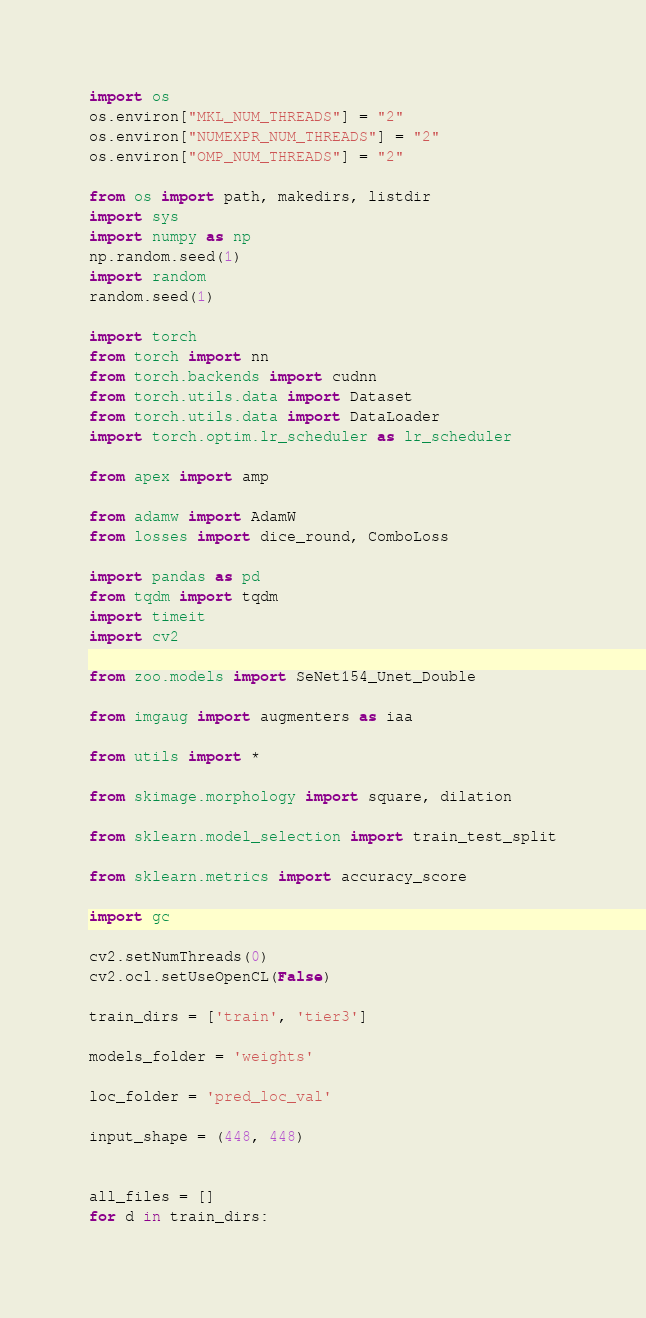<code> <loc_0><loc_0><loc_500><loc_500><_Python_>import os
os.environ["MKL_NUM_THREADS"] = "2" 
os.environ["NUMEXPR_NUM_THREADS"] = "2" 
os.environ["OMP_NUM_THREADS"] = "2" 

from os import path, makedirs, listdir
import sys
import numpy as np
np.random.seed(1)
import random
random.seed(1)

import torch
from torch import nn
from torch.backends import cudnn
from torch.utils.data import Dataset
from torch.utils.data import DataLoader
import torch.optim.lr_scheduler as lr_scheduler

from apex import amp

from adamw import AdamW
from losses import dice_round, ComboLoss

import pandas as pd
from tqdm import tqdm
import timeit
import cv2

from zoo.models import SeNet154_Unet_Double

from imgaug import augmenters as iaa

from utils import *

from skimage.morphology import square, dilation

from sklearn.model_selection import train_test_split

from sklearn.metrics import accuracy_score

import gc

cv2.setNumThreads(0)
cv2.ocl.setUseOpenCL(False)

train_dirs = ['train', 'tier3']

models_folder = 'weights'

loc_folder = 'pred_loc_val'

input_shape = (448, 448)


all_files = []
for d in train_dirs:</code> 